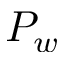<formula> <loc_0><loc_0><loc_500><loc_500>P _ { w }</formula> 